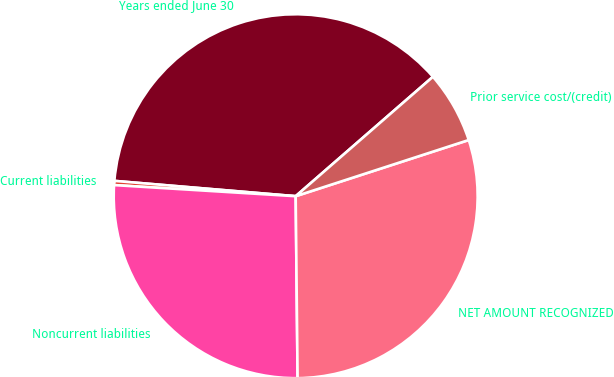<chart> <loc_0><loc_0><loc_500><loc_500><pie_chart><fcel>Years ended June 30<fcel>Current liabilities<fcel>Noncurrent liabilities<fcel>NET AMOUNT RECOGNIZED<fcel>Prior service cost/(credit)<nl><fcel>37.26%<fcel>0.37%<fcel>26.14%<fcel>29.83%<fcel>6.4%<nl></chart> 